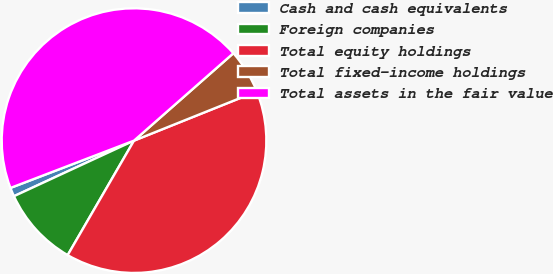Convert chart to OTSL. <chart><loc_0><loc_0><loc_500><loc_500><pie_chart><fcel>Cash and cash equivalents<fcel>Foreign companies<fcel>Total equity holdings<fcel>Total fixed-income holdings<fcel>Total assets in the fair value<nl><fcel>1.08%<fcel>9.74%<fcel>39.43%<fcel>5.41%<fcel>44.34%<nl></chart> 